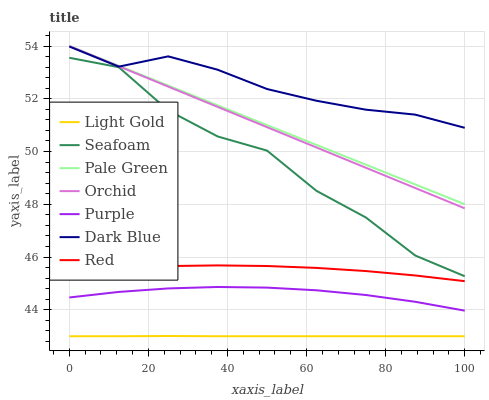Does Light Gold have the minimum area under the curve?
Answer yes or no. Yes. Does Dark Blue have the maximum area under the curve?
Answer yes or no. Yes. Does Seafoam have the minimum area under the curve?
Answer yes or no. No. Does Seafoam have the maximum area under the curve?
Answer yes or no. No. Is Orchid the smoothest?
Answer yes or no. Yes. Is Seafoam the roughest?
Answer yes or no. Yes. Is Dark Blue the smoothest?
Answer yes or no. No. Is Dark Blue the roughest?
Answer yes or no. No. Does Light Gold have the lowest value?
Answer yes or no. Yes. Does Seafoam have the lowest value?
Answer yes or no. No. Does Orchid have the highest value?
Answer yes or no. Yes. Does Seafoam have the highest value?
Answer yes or no. No. Is Light Gold less than Pale Green?
Answer yes or no. Yes. Is Red greater than Light Gold?
Answer yes or no. Yes. Does Dark Blue intersect Pale Green?
Answer yes or no. Yes. Is Dark Blue less than Pale Green?
Answer yes or no. No. Is Dark Blue greater than Pale Green?
Answer yes or no. No. Does Light Gold intersect Pale Green?
Answer yes or no. No. 